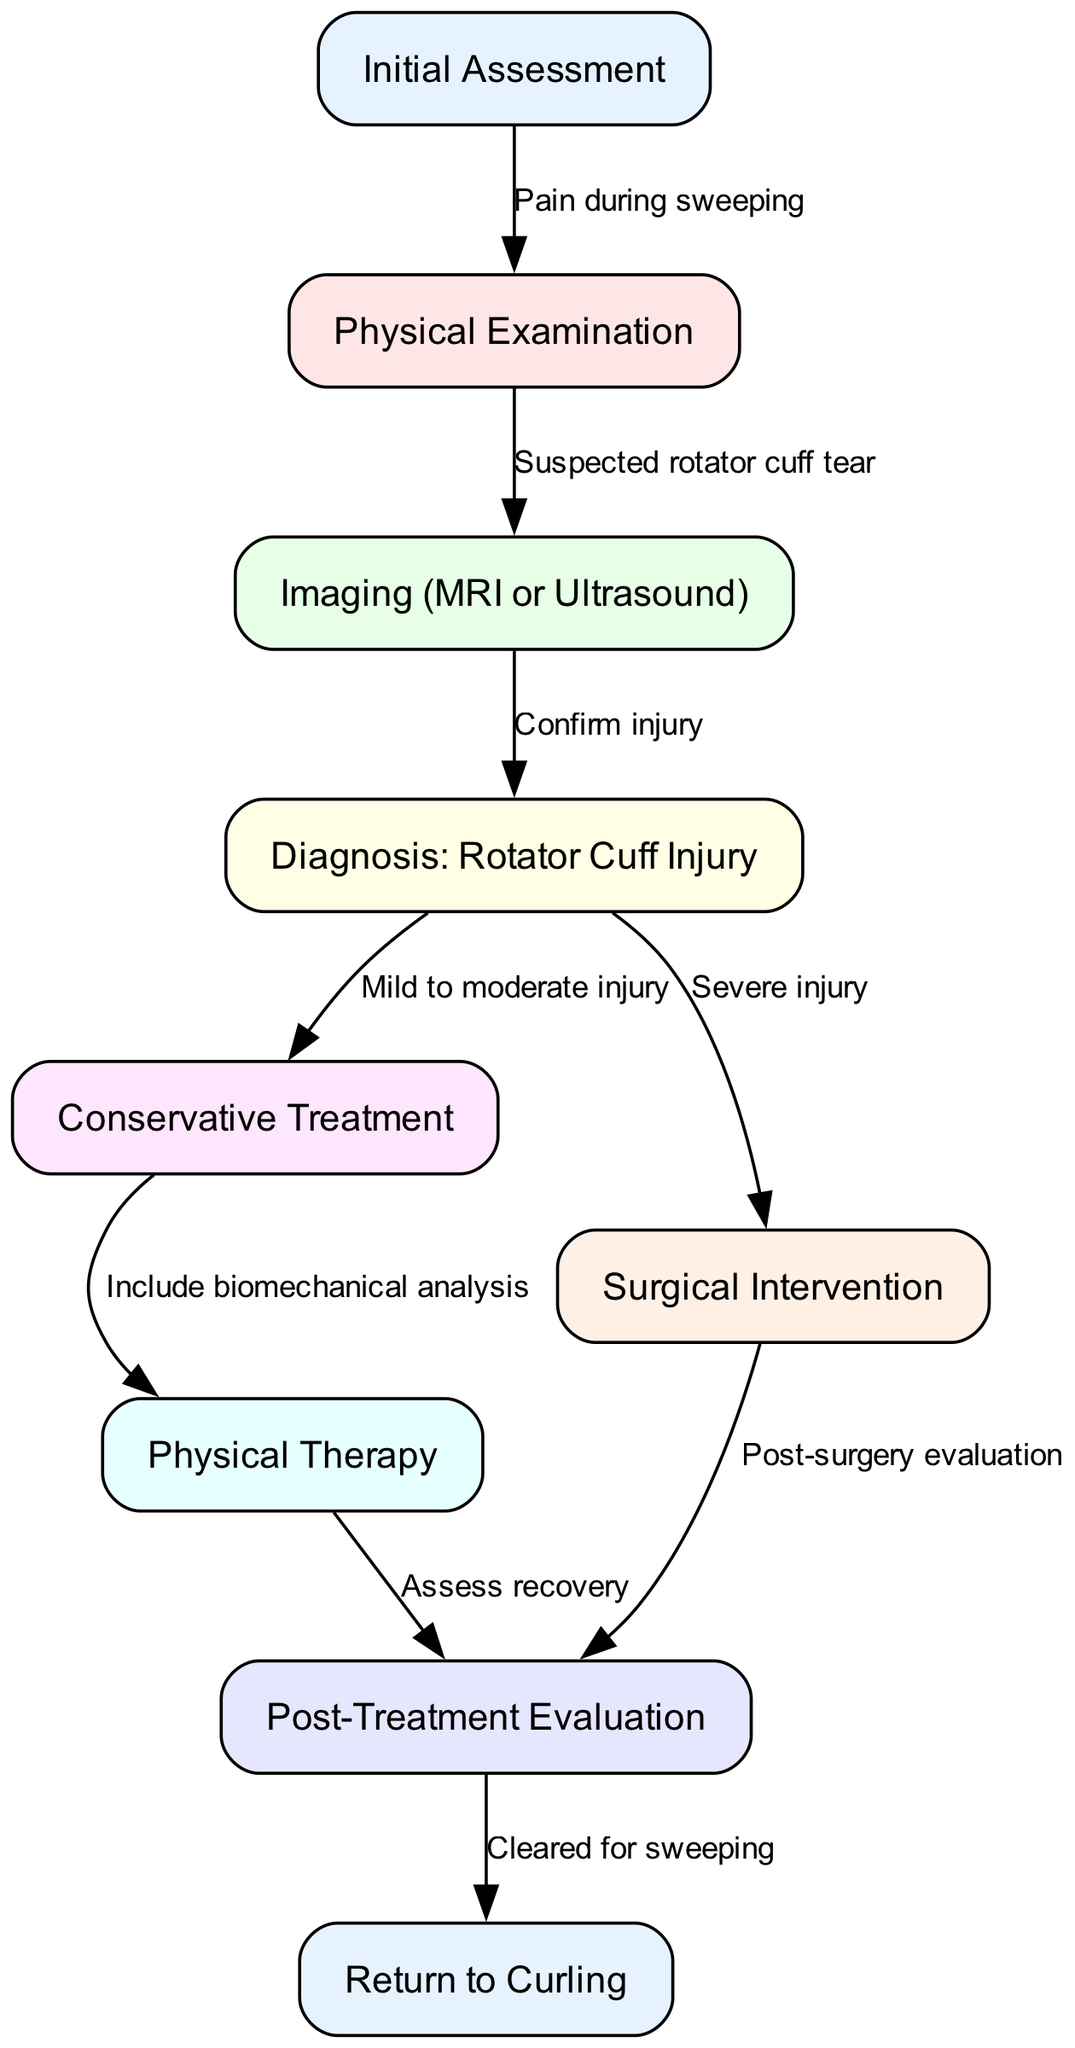What is the outcome of the initial assessment? The initial assessment leads to a physical examination when pain during sweeping is observed. This relationship is indicated by the edge connecting these two nodes.
Answer: Physical Examination How many nodes are in the diagram? The diagram contains eight unique process nodes, each representing a step in the pathway. Counting all nodes listed confirms this.
Answer: 9 What is the next step after diagnosing a rotator cuff injury? After the diagnosis of a rotator cuff injury, the next step is determined based on the severity of the injury, leading to either conservative treatment or surgical intervention.
Answer: Conservative Treatment or Surgical Intervention What indicates the need for post-surgery evaluation? The need for post-surgery evaluation arises from performing a surgical intervention, visualized by an edge connecting surgical intervention to post-surgery evaluation.
Answer: Surgical Intervention Which step includes biomechanical analysis? Biomechanical analysis is included in the physical therapy step, as indicated by the edge connecting conservative treatment to physical therapy.
Answer: Physical Therapy What connects diagnosis to conservative treatment? The connection from diagnosis to conservative treatment relies on the classification of the injury as mild to moderate, as shown by the corresponding edge in the diagram.
Answer: Mild to moderate injury What is the final outcome in the pathway? The final outcome of the pathway is a return to curling, which is reached after the post-treatment evaluation. This is established by the edge from post-treatment evaluation to the return to curling node.
Answer: Return to Curling What does imaging confirm? Imaging, such as MRI or ultrasound, confirms the diagnosis of a rotator cuff injury, as reflected in the directed edge in the diagram.
Answer: Confirm injury What step follows physical therapy? Following physical therapy, the next step is a post-treatment evaluation to assess recovery, as represented by the edge leading from physical therapy to post-treatment evaluation.
Answer: Post-Treatment Evaluation 